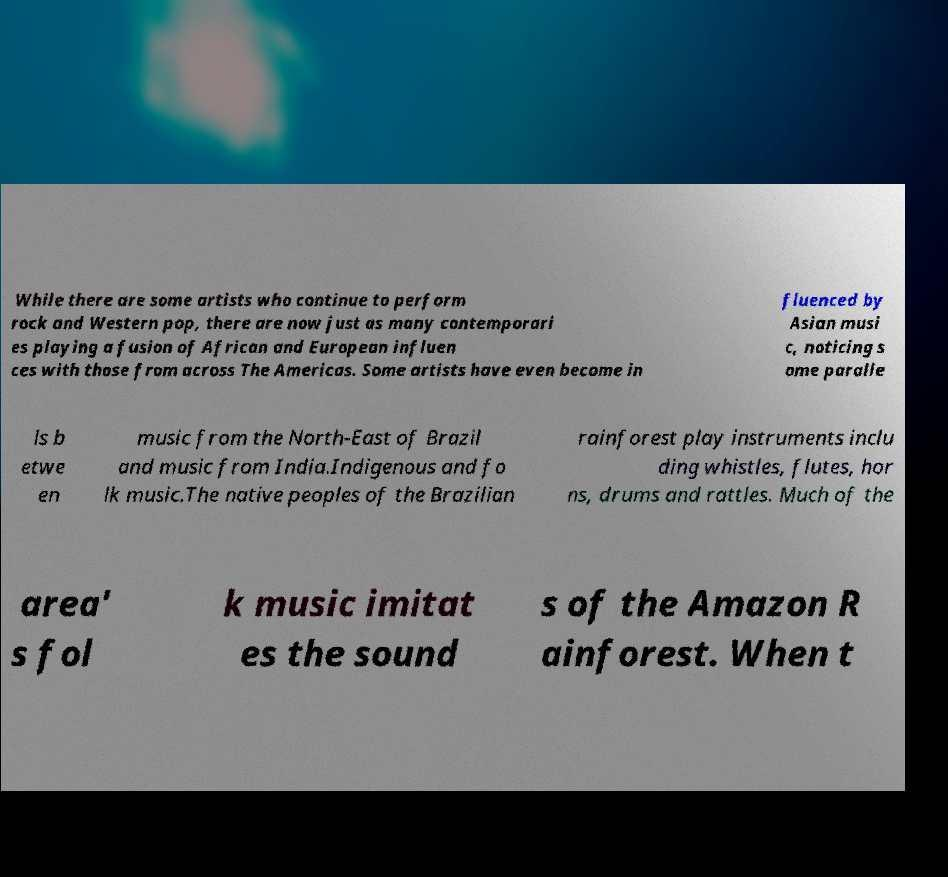For documentation purposes, I need the text within this image transcribed. Could you provide that? While there are some artists who continue to perform rock and Western pop, there are now just as many contemporari es playing a fusion of African and European influen ces with those from across The Americas. Some artists have even become in fluenced by Asian musi c, noticing s ome paralle ls b etwe en music from the North-East of Brazil and music from India.Indigenous and fo lk music.The native peoples of the Brazilian rainforest play instruments inclu ding whistles, flutes, hor ns, drums and rattles. Much of the area' s fol k music imitat es the sound s of the Amazon R ainforest. When t 